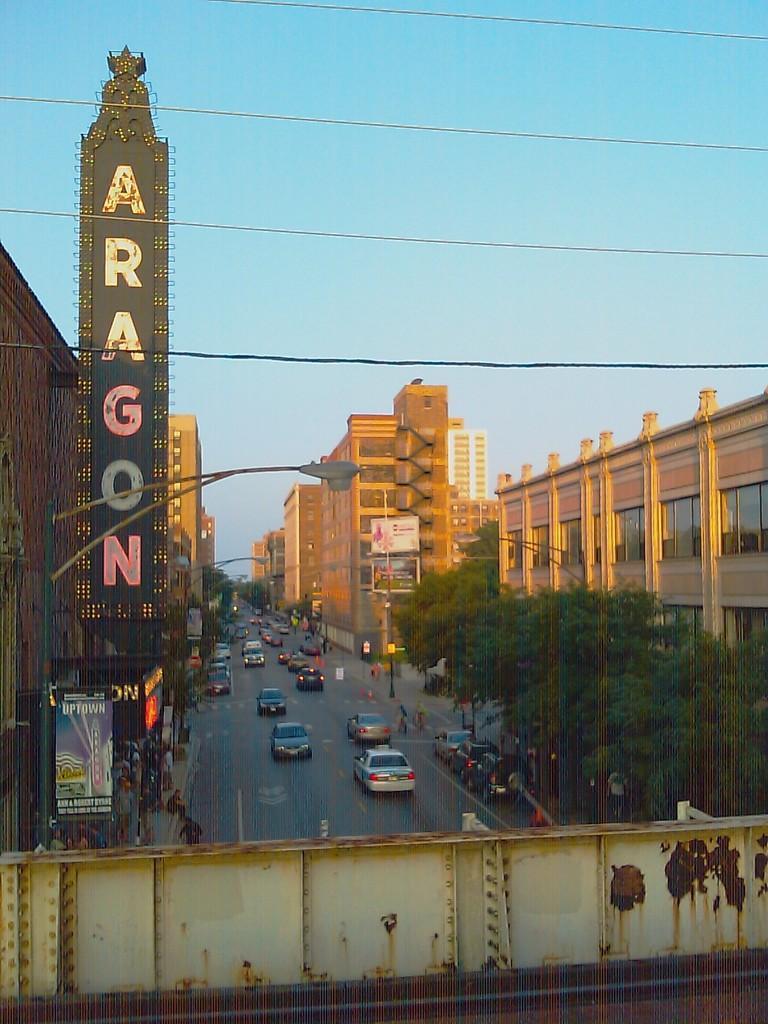How would you summarize this image in a sentence or two? In the image we can see there are many vehicles on the road. There are many buildings and windows of the building, light pole, electric wire and there are many people wearing clothes. This is a name plate and a sky. 